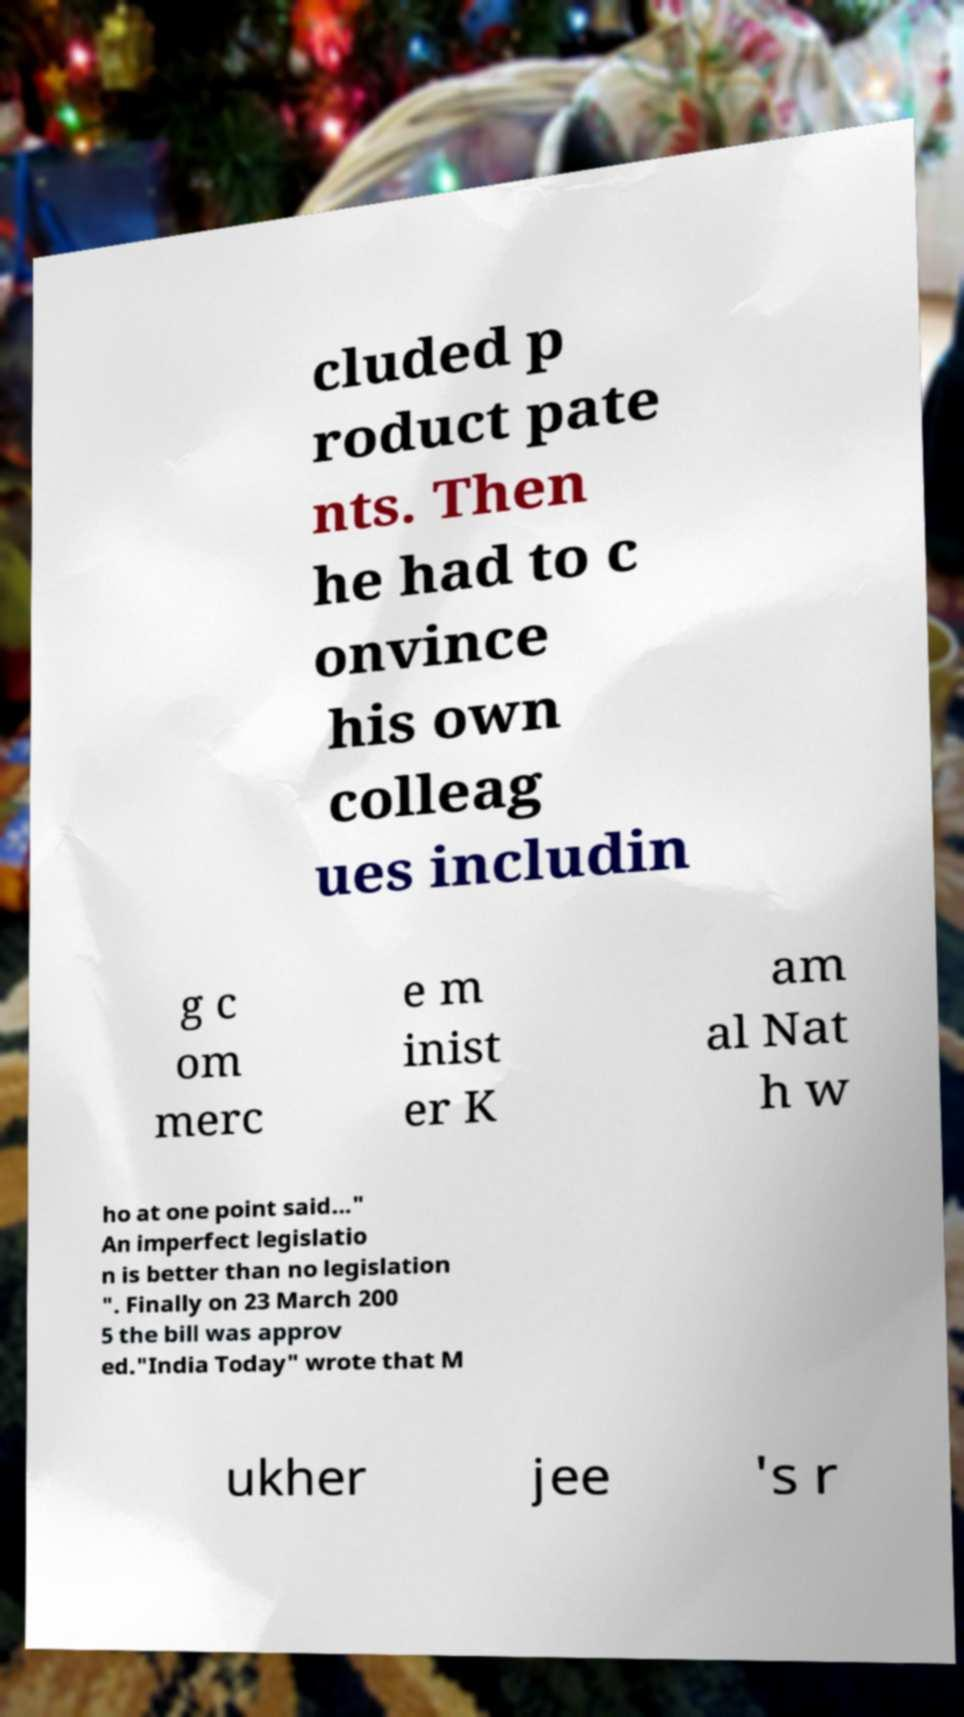What messages or text are displayed in this image? I need them in a readable, typed format. cluded p roduct pate nts. Then he had to c onvince his own colleag ues includin g c om merc e m inist er K am al Nat h w ho at one point said..." An imperfect legislatio n is better than no legislation ". Finally on 23 March 200 5 the bill was approv ed."India Today" wrote that M ukher jee 's r 